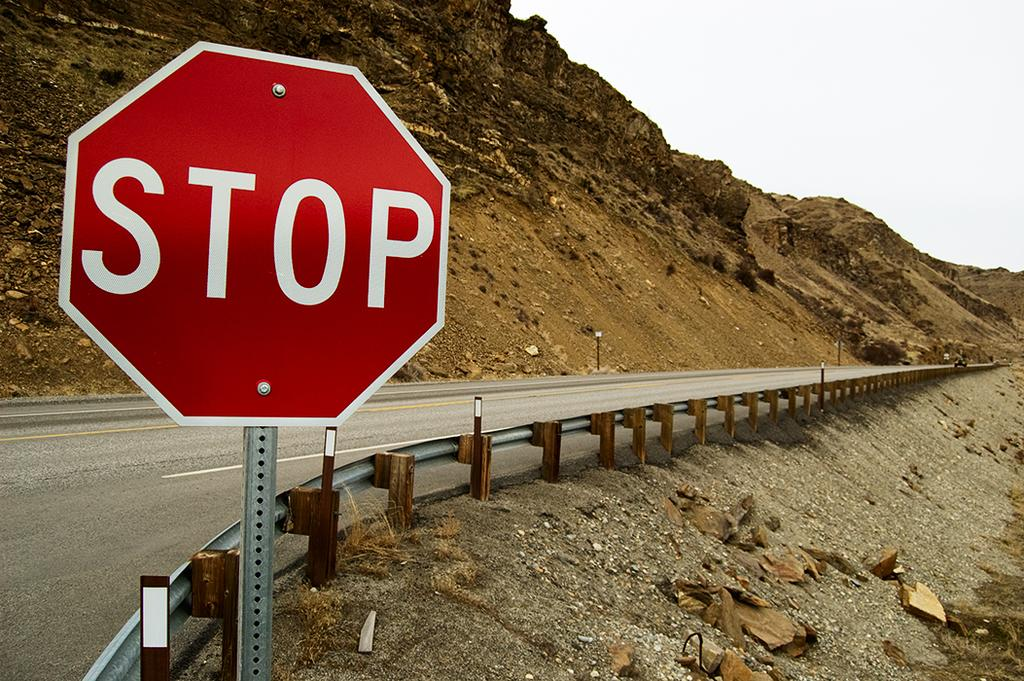Provide a one-sentence caption for the provided image. A stop sign is on the side of an empty road behind railing. 